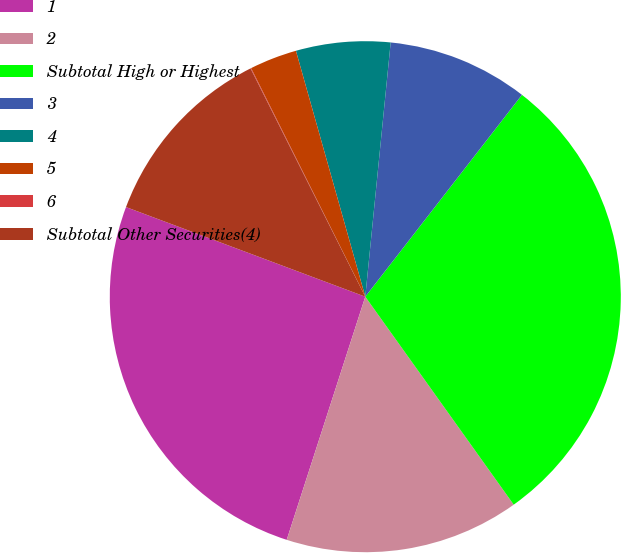Convert chart. <chart><loc_0><loc_0><loc_500><loc_500><pie_chart><fcel>1<fcel>2<fcel>Subtotal High or Highest<fcel>3<fcel>4<fcel>5<fcel>6<fcel>Subtotal Other Securities(4)<nl><fcel>25.73%<fcel>14.84%<fcel>29.63%<fcel>8.92%<fcel>5.96%<fcel>3.0%<fcel>0.04%<fcel>11.88%<nl></chart> 